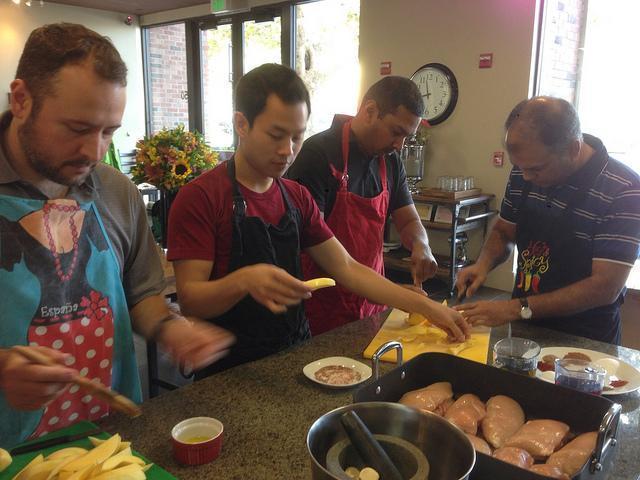What do these people do here?
Answer the question by selecting the correct answer among the 4 following choices and explain your choice with a short sentence. The answer should be formatted with the following format: `Answer: choice
Rationale: rationale.`
Options: Sing, watch youtube, watch tv, cook. Answer: cook.
Rationale: The people are visibly preparing food and putting them in vessels that would be used for the purposes of answer a. 